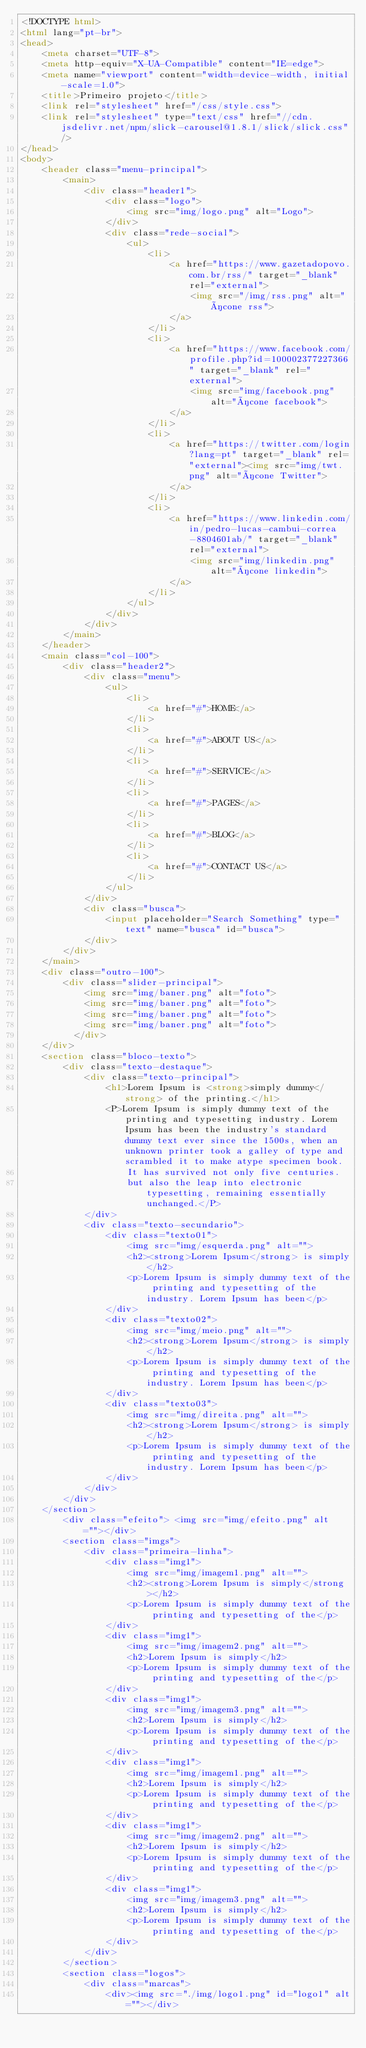<code> <loc_0><loc_0><loc_500><loc_500><_HTML_><!DOCTYPE html>
<html lang="pt-br">
<head>
    <meta charset="UTF-8">
    <meta http-equiv="X-UA-Compatible" content="IE=edge">
    <meta name="viewport" content="width=device-width, initial-scale=1.0">
    <title>Primeiro projeto</title>
    <link rel="stylesheet" href="/css/style.css">
    <link rel="stylesheet" type="text/css" href="//cdn.jsdelivr.net/npm/slick-carousel@1.8.1/slick/slick.css"/>
</head>
<body>
    <header class="menu-principal">
        <main>
            <div class="header1">
                <div class="logo">
                    <img src="img/logo.png" alt="Logo">
                </div>
                <div class="rede-social">
                    <ul>
                        <li>
                            <a href="https://www.gazetadopovo.com.br/rss/" target="_blank" rel="external">
                                <img src="/img/rss.png" alt="ícone rss">
                            </a>
                        </li>
                        <li>
                            <a href="https://www.facebook.com/profile.php?id=100002377227366" target="_blank" rel="external">
                                <img src="img/facebook.png" alt="ícone facebook">
                            </a>
                        </li>
                        <li>
                            <a href="https://twitter.com/login?lang=pt" target="_blank" rel="external"><img src="img/twt.png" alt="ícone Twitter">
                            </a>
                        </li>
                        <li>
                            <a href="https://www.linkedin.com/in/pedro-lucas-cambui-correa-8804601ab/" target="_blank" rel="external">
                                <img src="img/linkedin.png" alt="ícone linkedin">
                            </a>
                        </li>
                    </ul>
                </div>
            </div>
        </main>
    </header>
    <main class="col-100">
        <div class="header2">
            <div class="menu">
                <ul>
                    <li>
                        <a href="#">HOME</a>
                    </li>
                    <li>
                        <a href="#">ABOUT US</a>
                    </li>
                    <li>
                        <a href="#">SERVICE</a>
                    </li>
                    <li>
                        <a href="#">PAGES</a>
                    </li>
                    <li>
                        <a href="#">BLOG</a>
                    </li>
                    <li>
                        <a href="#">CONTACT US</a>
                    </li>
                </ul>
            </div>
            <div class="busca">
                <input placeholder="Search Something" type="text" name="busca" id="busca">
            </div>
        </div>
    </main>
    <div class="outro-100">
        <div class="slider-principal">
            <img src="img/baner.png" alt="foto">
            <img src="img/baner.png" alt="foto">
            <img src="img/baner.png" alt="foto">
            <img src="img/baner.png" alt="foto">
          </div>
    </div>
    <section class="bloco-texto">
        <div class="texto-destaque">
            <div class="texto-principal">
                <h1>Lorem Ipsum is <strong>simply dummy</strong> of the printing.</h1>
                <P>Lorem Ipsum is simply dummy text of the printing and typesetting industry. Lorem Ipsum has been the industry's standard dummy text ever since the 1500s, when an unknown printer took a galley of type and scrambled it to make atype specimen book.
                    It has survived not only five centuries.
                    but also the leap into electronic typesetting, remaining essentially unchanged.</P>
            </div>
            <div class="texto-secundario">
                <div class="texto01">
                    <img src="img/esquerda.png" alt="">
                    <h2><strong>Lorem Ipsum</strong> is simply</h2>
                    <p>Lorem Ipsum is simply dummy text of the printing and typesetting of the industry. Lorem Ipsum has been</p>
                </div>
                <div class="texto02">
                    <img src="img/meio.png" alt="">
                    <h2><strong>Lorem Ipsum</strong> is simply</h2>
                    <p>Lorem Ipsum is simply dummy text of the printing and typesetting of the industry. Lorem Ipsum has been</p>
                </div>
                <div class="texto03">
                    <img src="img/direita.png" alt="">
                    <h2><strong>Lorem Ipsum</strong> is simply</h2>
                    <p>Lorem Ipsum is simply dummy text of the printing and typesetting of the industry. Lorem Ipsum has been</p>
                </div>
            </div>
        </div>
    </section>
        <div class="efeito"> <img src="img/efeito.png" alt=""></div>
        <section class="imgs">
            <div class="primeira-linha">
                <div class="img1">
                    <img src="img/imagem1.png" alt="">
                    <h2><strong>Lorem Ipsum is simply</strong></h2>
                    <p>Lorem Ipsum is simply dummy text of the printing and typesetting of the</p>
                </div>
                <div class="img1">
                    <img src="img/imagem2.png" alt="">
                    <h2>Lorem Ipsum is simply</h2>
                    <p>Lorem Ipsum is simply dummy text of the printing and typesetting of the</p>
                </div>
                <div class="img1">
                    <img src="img/imagem3.png" alt="">
                    <h2>Lorem Ipsum is simply</h2>
                    <p>Lorem Ipsum is simply dummy text of the printing and typesetting of the</p>
                </div>
                <div class="img1">
                    <img src="img/imagem1.png" alt="">
                    <h2>Lorem Ipsum is simply</h2>
                    <p>Lorem Ipsum is simply dummy text of the printing and typesetting of the</p>
                </div>
                <div class="img1">
                    <img src="img/imagem2.png" alt="">
                    <h2>Lorem Ipsum is simply</h2>
                    <p>Lorem Ipsum is simply dummy text of the printing and typesetting of the</p>
                </div>
                <div class="img1">
                    <img src="img/imagem3.png" alt="">
                    <h2>Lorem Ipsum is simply</h2>
                    <p>Lorem Ipsum is simply dummy text of the printing and typesetting of the</p>
                </div>
            </div>
        </section>
        <section class="logos">
            <div class="marcas">
                <div><img src="./img/logo1.png" id="logo1" alt=""></div></code> 